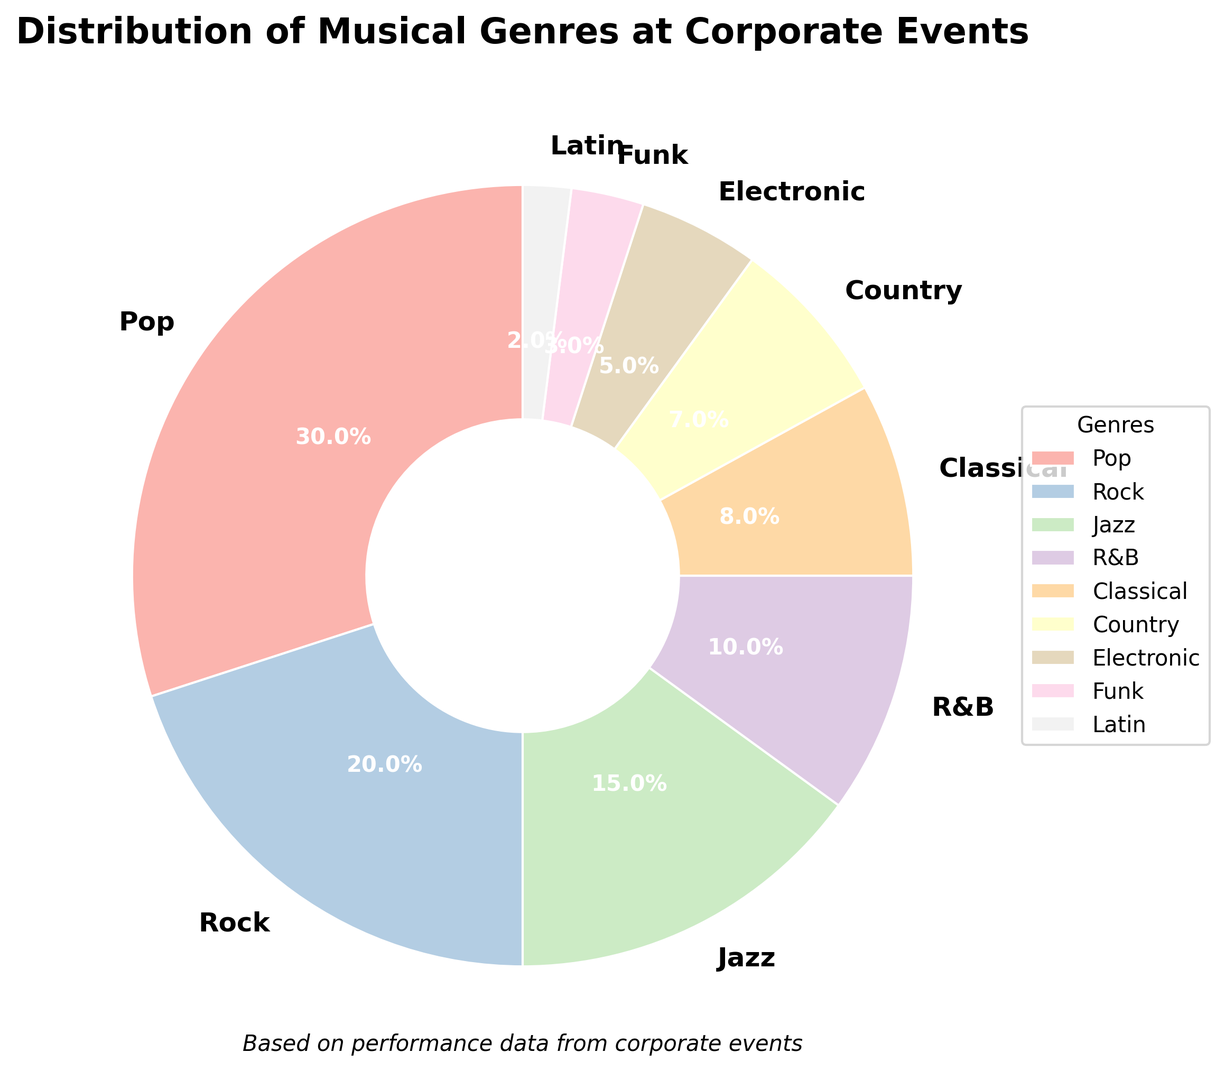What’s the most performed musical genre at corporate events? The pie chart shows that the largest section is labeled "Pop" with 30%. This indicates that Pop is the most performed genre.
Answer: Pop Which is more performed at corporate events: Jazz or Classical? By comparing the two sections of the pie chart, Jazz is 15% while Classical is 8%. Since 15% is greater than 8%, Jazz is more performed than Classical.
Answer: Jazz What is the total percentage of Pop and Rock performances? According to the chart, Pop makes up 30% and Rock makes up 20%. Adding these together, 30% + 20% = 50%.
Answer: 50% Which genre is performed the least at corporate events? The smallest section in the pie chart is labeled "Latin" with 2%. Thus, Latin is the least performed genre.
Answer: Latin How much more is the percentage of Pop performances compared to Electronic performances? From the pie chart, Pop is 30% and Electronic is 5%. The difference is 30% - 5% = 25%.
Answer: 25% Is the percentage of Rock performances more than double that of Country performances? Rock is 20% and Country is 7% according to the chart. Double the percentage of Country is 7% * 2 = 14%. Since 20% is greater than 14%, Rock performances are indeed more than double compared to Country.
Answer: Yes What is the combined percentage of R&B, Classical, and Latin performances? The chart shows R&B at 10%, Classical at 8%, and Latin at 2%. Adding these, 10% + 8% + 2% = 20%.
Answer: 20% What visual attribute distinguishes the wedges in the pie chart? Each wedge in the pie chart is distinguished by different colors.
Answer: Colors By how much does the percentage of Jazz performances exceed Funk performances? From the pie chart, Jazz is 15% and Funk is 3%. The difference is 15% - 3% = 12%.
Answer: 12% Which genres together make up more than half of the total performances? Adding the percentages: Pop (30%) + Rock (20%) = 50%. To exceed 50%, we need to add another genre. Adding Jazz (15%) makes 50% + 15% = 65%. Thus, Pop, Rock, and Jazz together make up more than half.
Answer: Pop, Rock, Jazz 